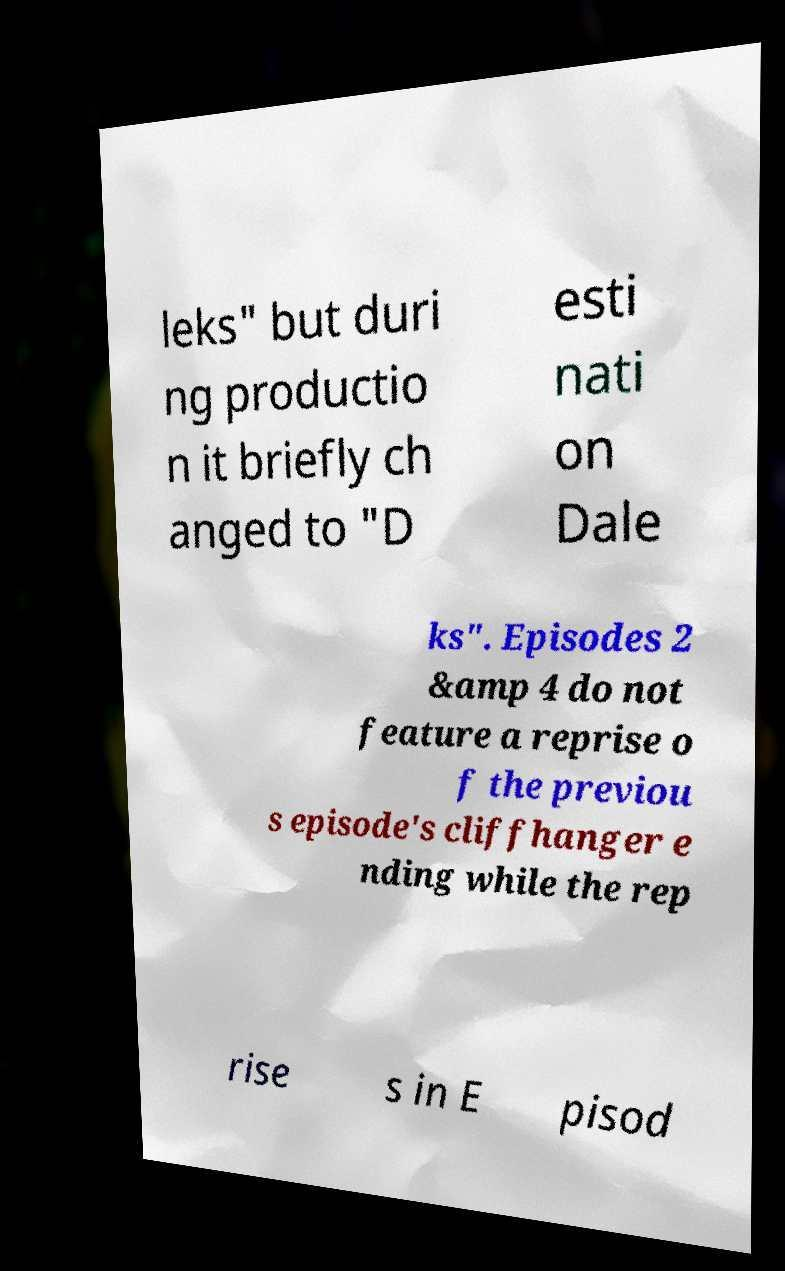Please read and relay the text visible in this image. What does it say? leks" but duri ng productio n it briefly ch anged to "D esti nati on Dale ks". Episodes 2 &amp 4 do not feature a reprise o f the previou s episode's cliffhanger e nding while the rep rise s in E pisod 